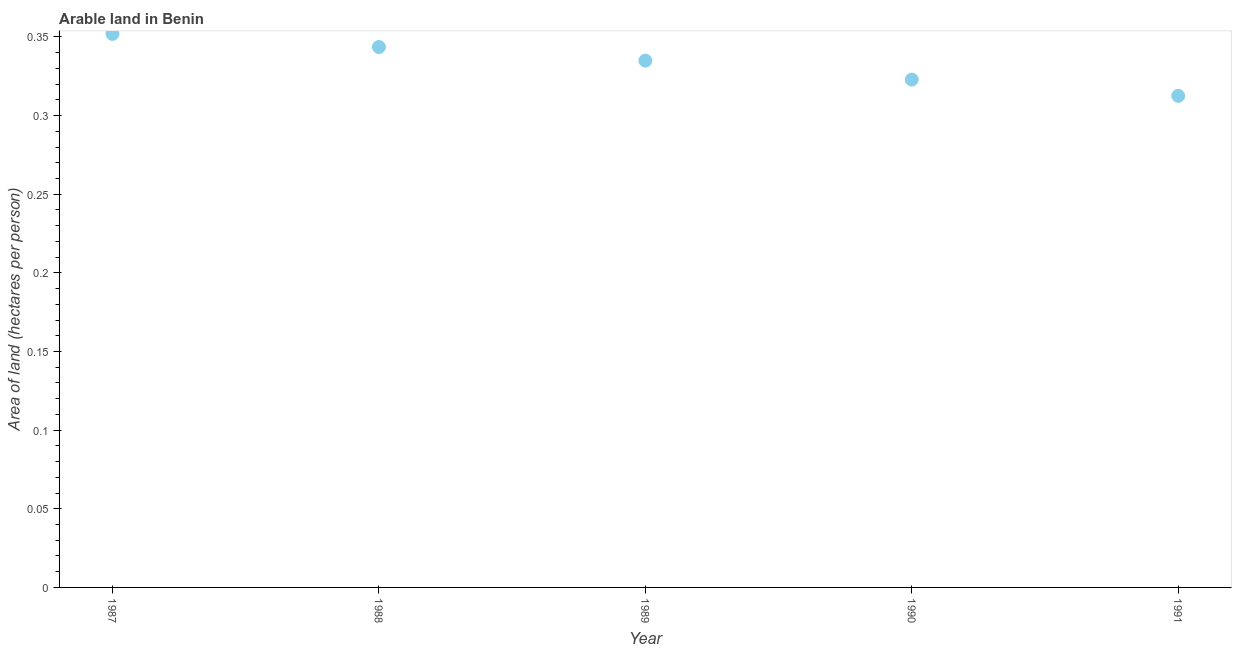What is the area of arable land in 1987?
Your response must be concise. 0.35. Across all years, what is the maximum area of arable land?
Ensure brevity in your answer.  0.35. Across all years, what is the minimum area of arable land?
Your response must be concise. 0.31. In which year was the area of arable land maximum?
Ensure brevity in your answer.  1987. In which year was the area of arable land minimum?
Your response must be concise. 1991. What is the sum of the area of arable land?
Your answer should be compact. 1.67. What is the difference between the area of arable land in 1989 and 1991?
Ensure brevity in your answer.  0.02. What is the average area of arable land per year?
Your answer should be compact. 0.33. What is the median area of arable land?
Give a very brief answer. 0.33. In how many years, is the area of arable land greater than 0.1 hectares per person?
Provide a succinct answer. 5. What is the ratio of the area of arable land in 1988 to that in 1991?
Your answer should be very brief. 1.1. Is the difference between the area of arable land in 1990 and 1991 greater than the difference between any two years?
Make the answer very short. No. What is the difference between the highest and the second highest area of arable land?
Give a very brief answer. 0.01. Is the sum of the area of arable land in 1988 and 1991 greater than the maximum area of arable land across all years?
Offer a terse response. Yes. What is the difference between the highest and the lowest area of arable land?
Offer a very short reply. 0.04. In how many years, is the area of arable land greater than the average area of arable land taken over all years?
Your answer should be compact. 3. How many dotlines are there?
Offer a terse response. 1. How many years are there in the graph?
Provide a succinct answer. 5. What is the difference between two consecutive major ticks on the Y-axis?
Offer a very short reply. 0.05. Are the values on the major ticks of Y-axis written in scientific E-notation?
Ensure brevity in your answer.  No. Does the graph contain grids?
Keep it short and to the point. No. What is the title of the graph?
Make the answer very short. Arable land in Benin. What is the label or title of the Y-axis?
Your answer should be compact. Area of land (hectares per person). What is the Area of land (hectares per person) in 1987?
Ensure brevity in your answer.  0.35. What is the Area of land (hectares per person) in 1988?
Provide a short and direct response. 0.34. What is the Area of land (hectares per person) in 1989?
Offer a terse response. 0.33. What is the Area of land (hectares per person) in 1990?
Give a very brief answer. 0.32. What is the Area of land (hectares per person) in 1991?
Your answer should be very brief. 0.31. What is the difference between the Area of land (hectares per person) in 1987 and 1988?
Make the answer very short. 0.01. What is the difference between the Area of land (hectares per person) in 1987 and 1989?
Keep it short and to the point. 0.02. What is the difference between the Area of land (hectares per person) in 1987 and 1990?
Provide a succinct answer. 0.03. What is the difference between the Area of land (hectares per person) in 1987 and 1991?
Make the answer very short. 0.04. What is the difference between the Area of land (hectares per person) in 1988 and 1989?
Your answer should be compact. 0.01. What is the difference between the Area of land (hectares per person) in 1988 and 1990?
Ensure brevity in your answer.  0.02. What is the difference between the Area of land (hectares per person) in 1988 and 1991?
Provide a short and direct response. 0.03. What is the difference between the Area of land (hectares per person) in 1989 and 1990?
Your response must be concise. 0.01. What is the difference between the Area of land (hectares per person) in 1989 and 1991?
Offer a very short reply. 0.02. What is the difference between the Area of land (hectares per person) in 1990 and 1991?
Give a very brief answer. 0.01. What is the ratio of the Area of land (hectares per person) in 1987 to that in 1988?
Your answer should be very brief. 1.02. What is the ratio of the Area of land (hectares per person) in 1987 to that in 1989?
Your response must be concise. 1.05. What is the ratio of the Area of land (hectares per person) in 1987 to that in 1990?
Your response must be concise. 1.09. What is the ratio of the Area of land (hectares per person) in 1987 to that in 1991?
Make the answer very short. 1.13. What is the ratio of the Area of land (hectares per person) in 1988 to that in 1990?
Offer a very short reply. 1.06. What is the ratio of the Area of land (hectares per person) in 1988 to that in 1991?
Provide a short and direct response. 1.1. What is the ratio of the Area of land (hectares per person) in 1989 to that in 1991?
Your response must be concise. 1.07. What is the ratio of the Area of land (hectares per person) in 1990 to that in 1991?
Your answer should be compact. 1.03. 